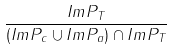<formula> <loc_0><loc_0><loc_500><loc_500>\frac { I m P _ { T } } { ( I m P _ { c } \cup I m P _ { a } ) \cap I m P _ { T } }</formula> 